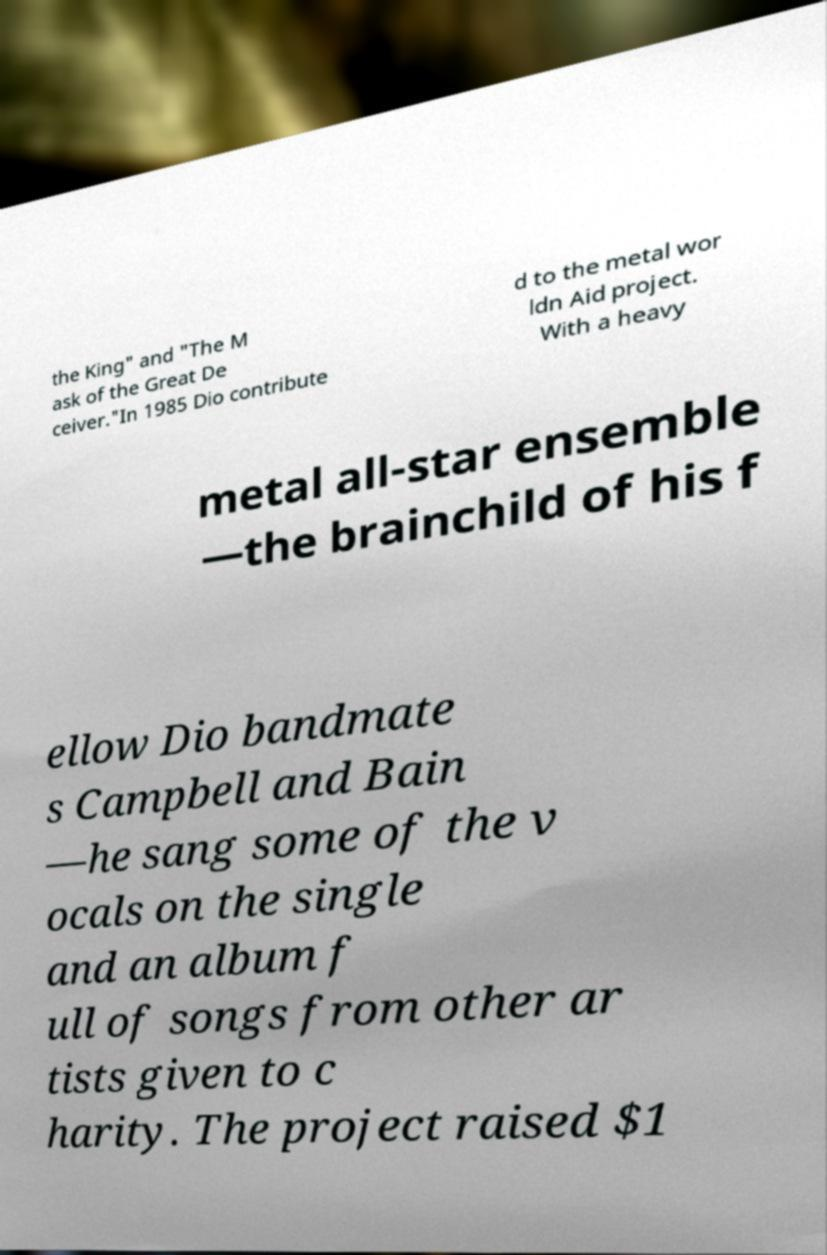There's text embedded in this image that I need extracted. Can you transcribe it verbatim? the King" and "The M ask of the Great De ceiver."In 1985 Dio contribute d to the metal wor ldn Aid project. With a heavy metal all-star ensemble —the brainchild of his f ellow Dio bandmate s Campbell and Bain —he sang some of the v ocals on the single and an album f ull of songs from other ar tists given to c harity. The project raised $1 